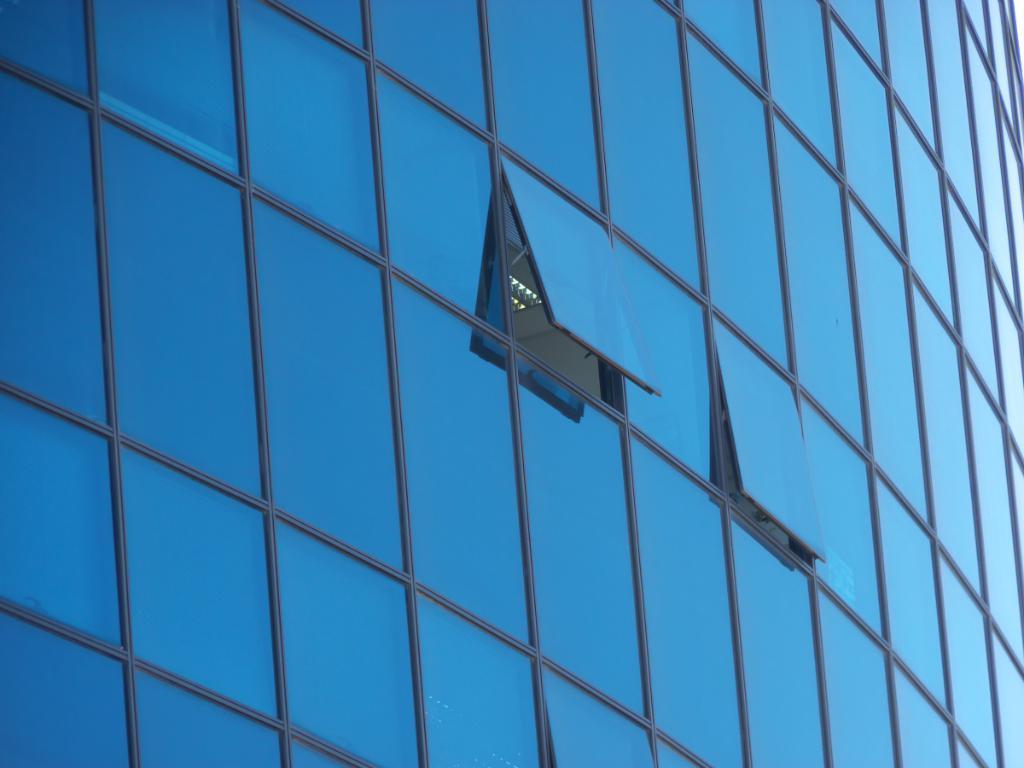In one or two sentences, can you explain what this image depicts? There is a building having blue colored glass windows. Two of them are partially opened. Through one of them, we can see there are lights. 